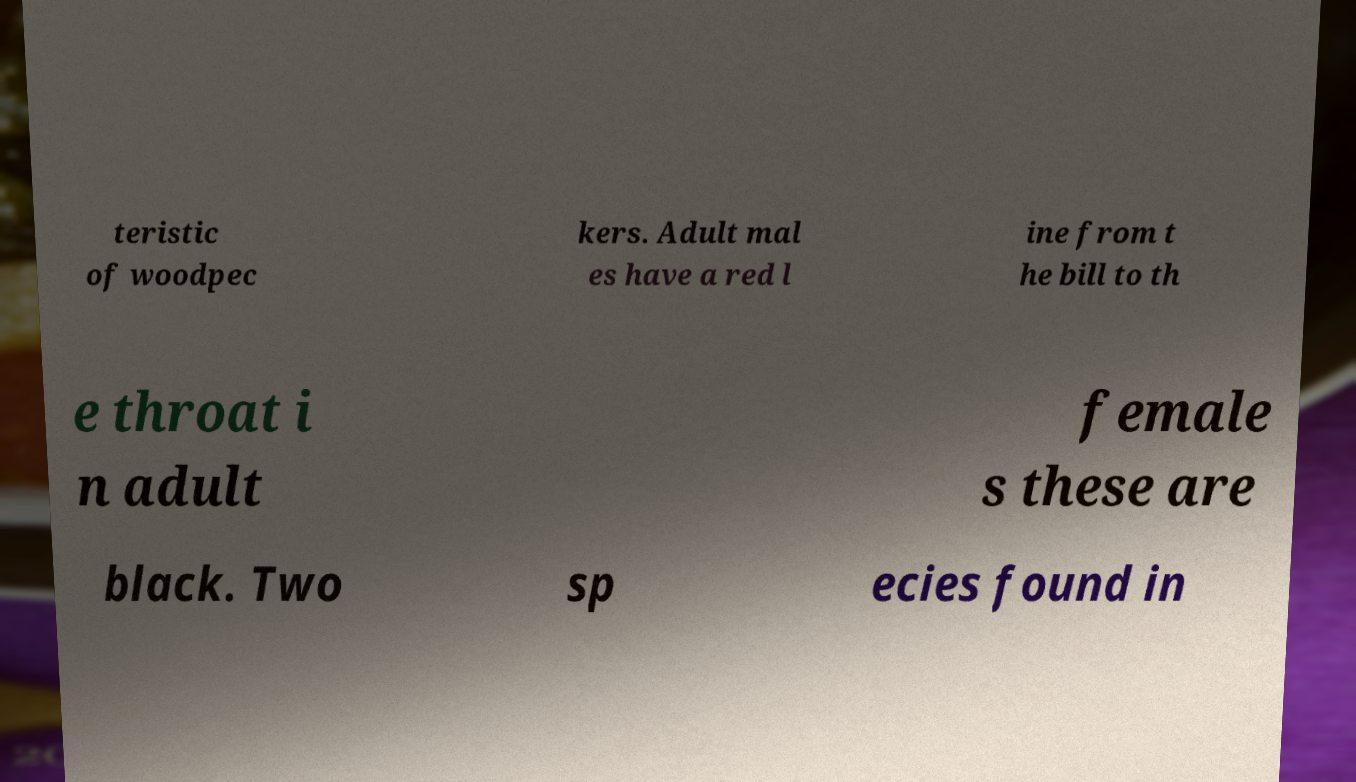What messages or text are displayed in this image? I need them in a readable, typed format. teristic of woodpec kers. Adult mal es have a red l ine from t he bill to th e throat i n adult female s these are black. Two sp ecies found in 